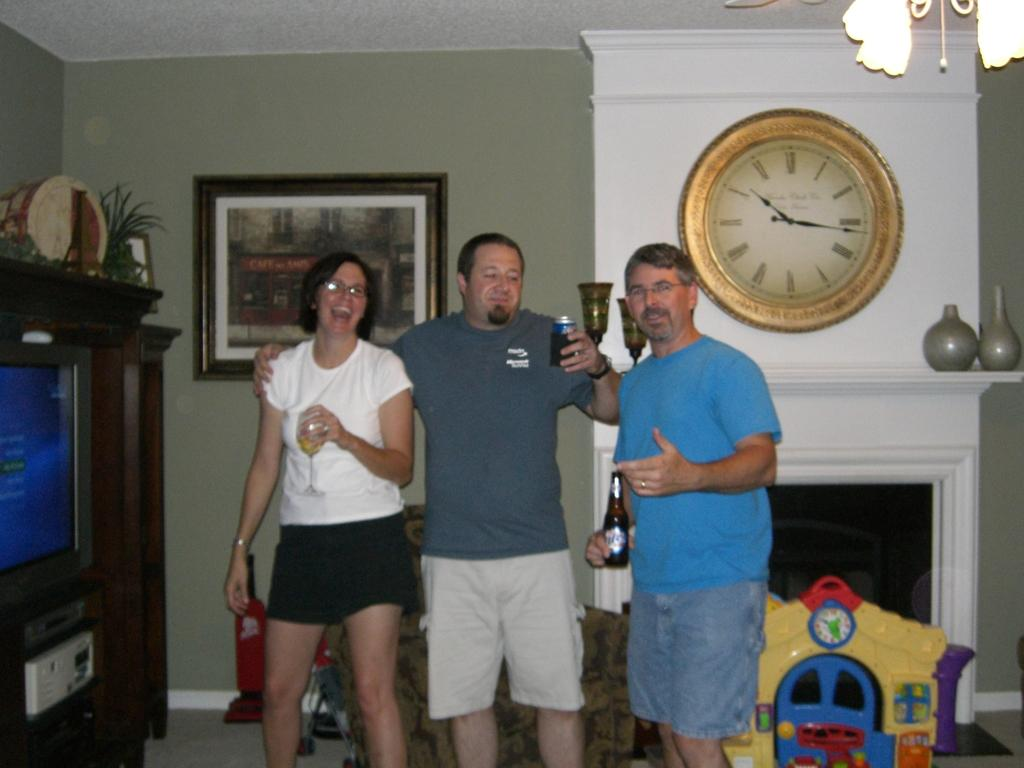<image>
Offer a succinct explanation of the picture presented. People standing together next to a clock which has the hands at 10 and 3. 